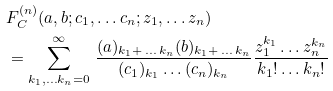Convert formula to latex. <formula><loc_0><loc_0><loc_500><loc_500>& F _ { C } ^ { ( n ) } ( a , b ; c _ { 1 } , \dots c _ { n } ; z _ { 1 } , \dots z _ { n } ) \\ & = \sum _ { k _ { 1 } , \dots k _ { n } = 0 } ^ { \infty } \, \frac { ( a ) _ { k _ { 1 } + \, \dots \, k _ { n } } ( b ) _ { k _ { 1 } + \, \dots \, k _ { n } } } { ( c _ { 1 } ) _ { k _ { 1 } } \dots ( c _ { n } ) _ { k _ { n } } } \frac { z _ { 1 } ^ { k _ { 1 } } \dots z _ { n } ^ { k _ { n } } } { k _ { 1 } ! \dots k _ { n } ! }</formula> 